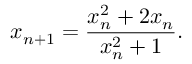Convert formula to latex. <formula><loc_0><loc_0><loc_500><loc_500>x _ { n + 1 } = { \frac { x _ { n } ^ { 2 } + 2 x _ { n } } { x _ { n } ^ { 2 } + 1 } } .</formula> 